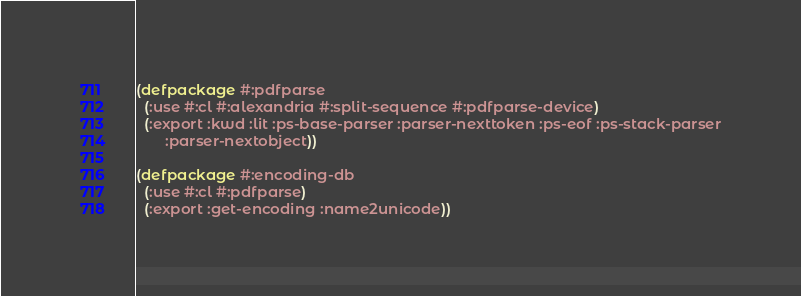<code> <loc_0><loc_0><loc_500><loc_500><_Lisp_>
(defpackage #:pdfparse
  (:use #:cl #:alexandria #:split-sequence #:pdfparse-device)
  (:export :kwd :lit :ps-base-parser :parser-nexttoken :ps-eof :ps-stack-parser
	   :parser-nextobject))

(defpackage #:encoding-db
  (:use #:cl #:pdfparse)
  (:export :get-encoding :name2unicode))
</code> 